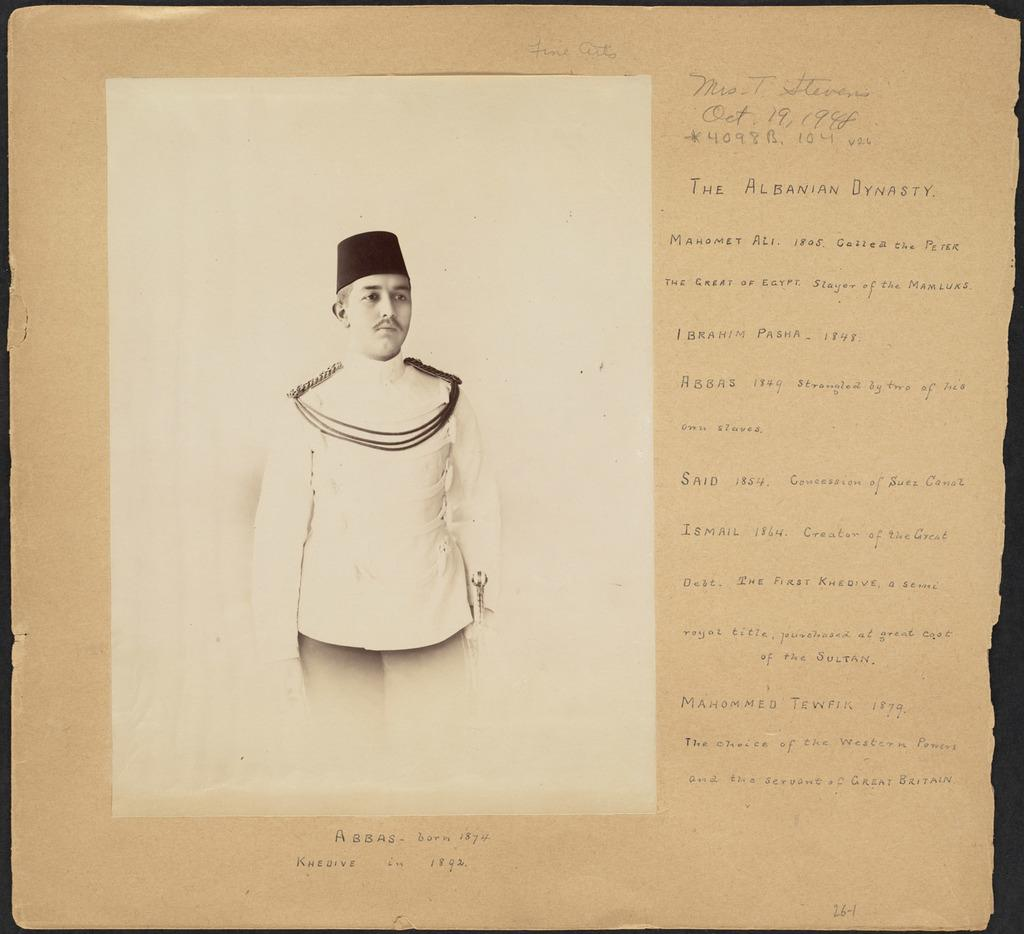What is written on the paper in the image? There is an article on the paper. Is there any visual element accompanying the article? Yes, there is a photo of a person on the paper. Where is the paper located in the image? The paper is placed on a surface. Can you tell me how many dinosaurs are in the photo on the paper? There are no dinosaurs present in the image, as the photo is of a person. 